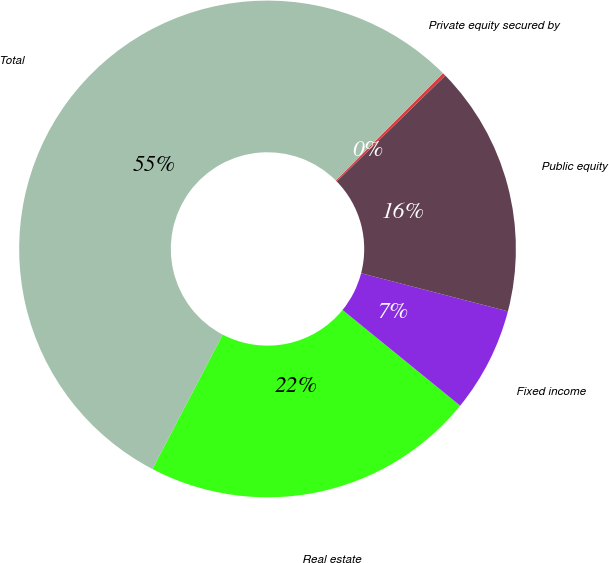<chart> <loc_0><loc_0><loc_500><loc_500><pie_chart><fcel>Real estate<fcel>Fixed income<fcel>Public equity<fcel>Private equity secured by<fcel>Total<nl><fcel>21.8%<fcel>6.83%<fcel>16.34%<fcel>0.21%<fcel>54.82%<nl></chart> 